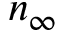<formula> <loc_0><loc_0><loc_500><loc_500>n _ { \infty }</formula> 